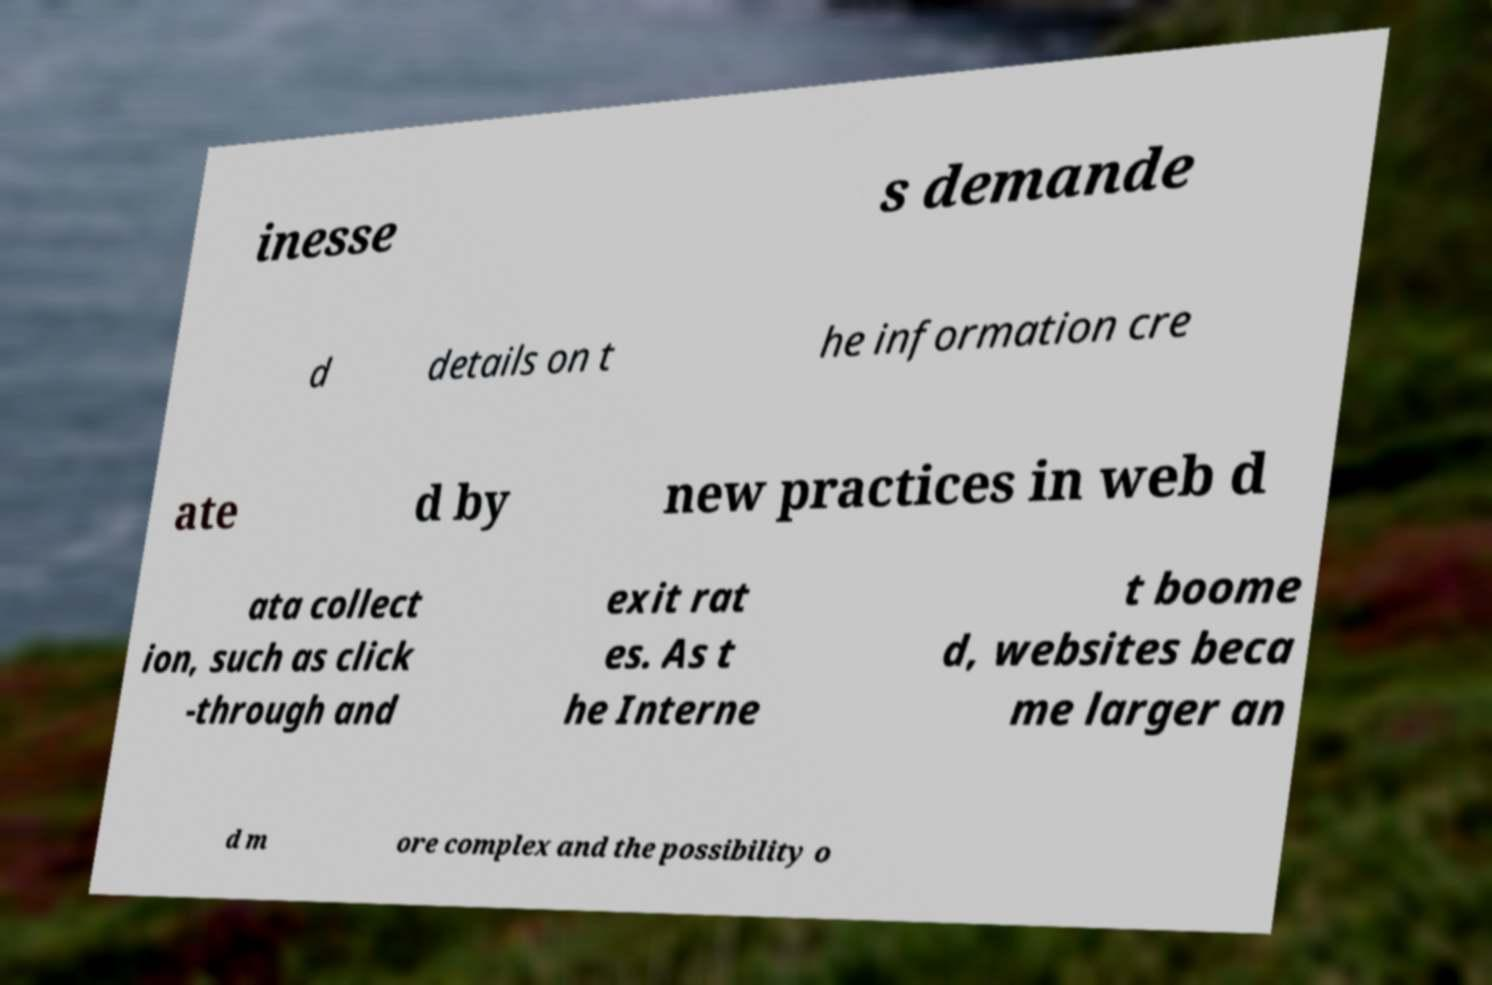Can you accurately transcribe the text from the provided image for me? inesse s demande d details on t he information cre ate d by new practices in web d ata collect ion, such as click -through and exit rat es. As t he Interne t boome d, websites beca me larger an d m ore complex and the possibility o 